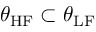Convert formula to latex. <formula><loc_0><loc_0><loc_500><loc_500>\theta _ { H F } \subset \theta _ { L F }</formula> 